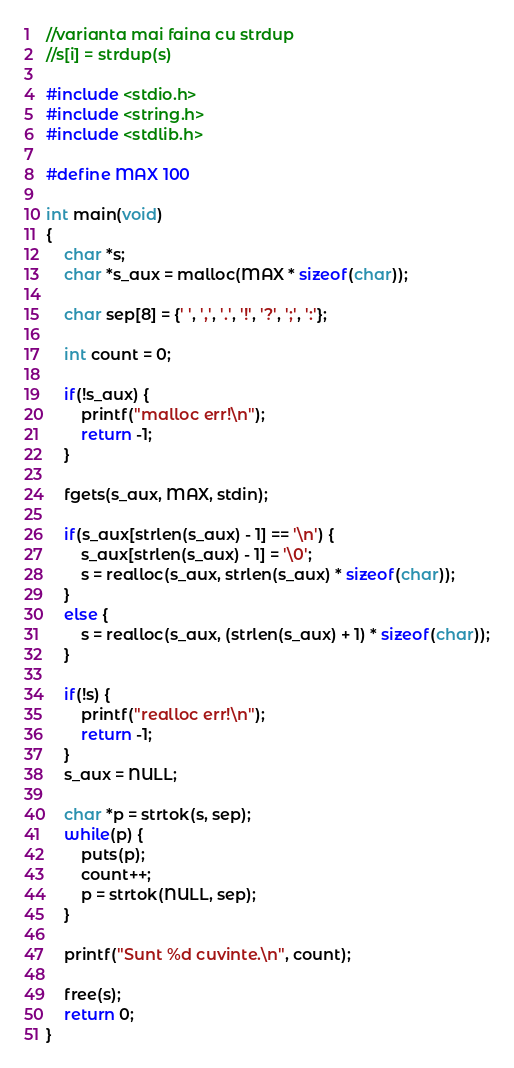Convert code to text. <code><loc_0><loc_0><loc_500><loc_500><_C_>//varianta mai faina cu strdup
//s[i] = strdup(s)

#include <stdio.h>
#include <string.h>
#include <stdlib.h>

#define MAX 100

int main(void)
{
    char *s;
    char *s_aux = malloc(MAX * sizeof(char));

    char sep[8] = {' ', ',', '.', '!', '?', ';', ':'};

    int count = 0;

    if(!s_aux) {
        printf("malloc err!\n");
        return -1;
    }

    fgets(s_aux, MAX, stdin);

    if(s_aux[strlen(s_aux) - 1] == '\n') {
        s_aux[strlen(s_aux) - 1] = '\0';
        s = realloc(s_aux, strlen(s_aux) * sizeof(char));
    }
    else {
        s = realloc(s_aux, (strlen(s_aux) + 1) * sizeof(char));
    }

    if(!s) {
        printf("realloc err!\n");
        return -1;
    }
    s_aux = NULL;

    char *p = strtok(s, sep);
    while(p) {
        puts(p);
        count++;
        p = strtok(NULL, sep);
    }

    printf("Sunt %d cuvinte.\n", count);

    free(s);
    return 0;
}</code> 